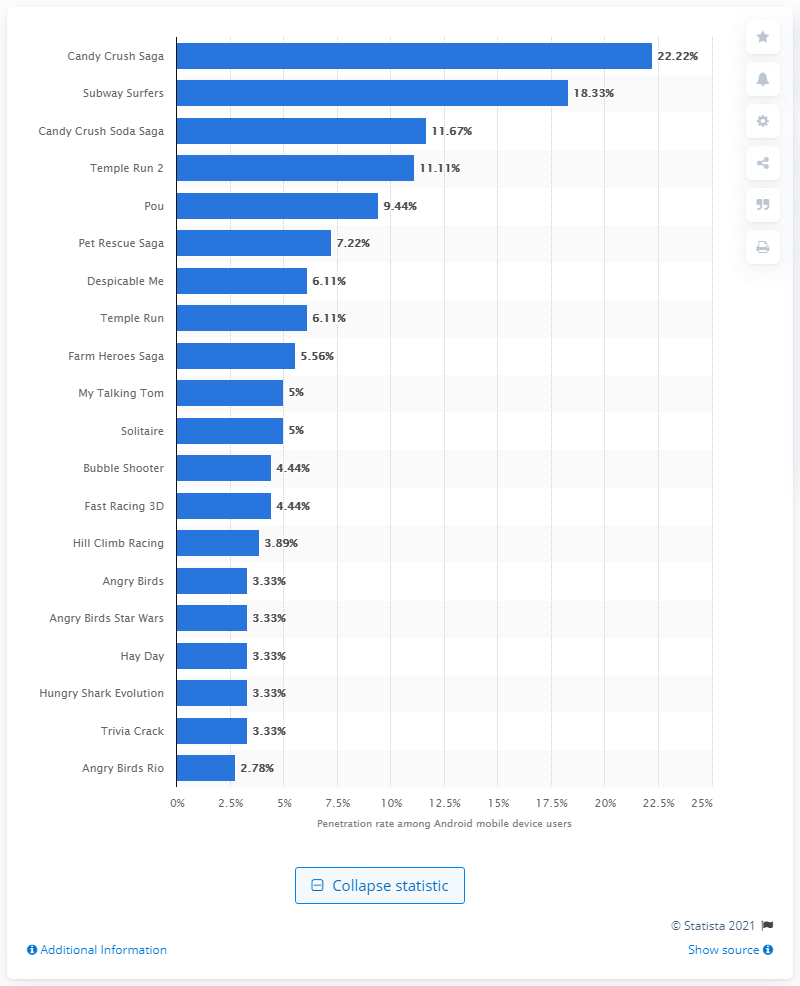Outline some significant characteristics in this image. Candy Crush Saga had a reach of 22.22% among Android mobile device users in the UK. 